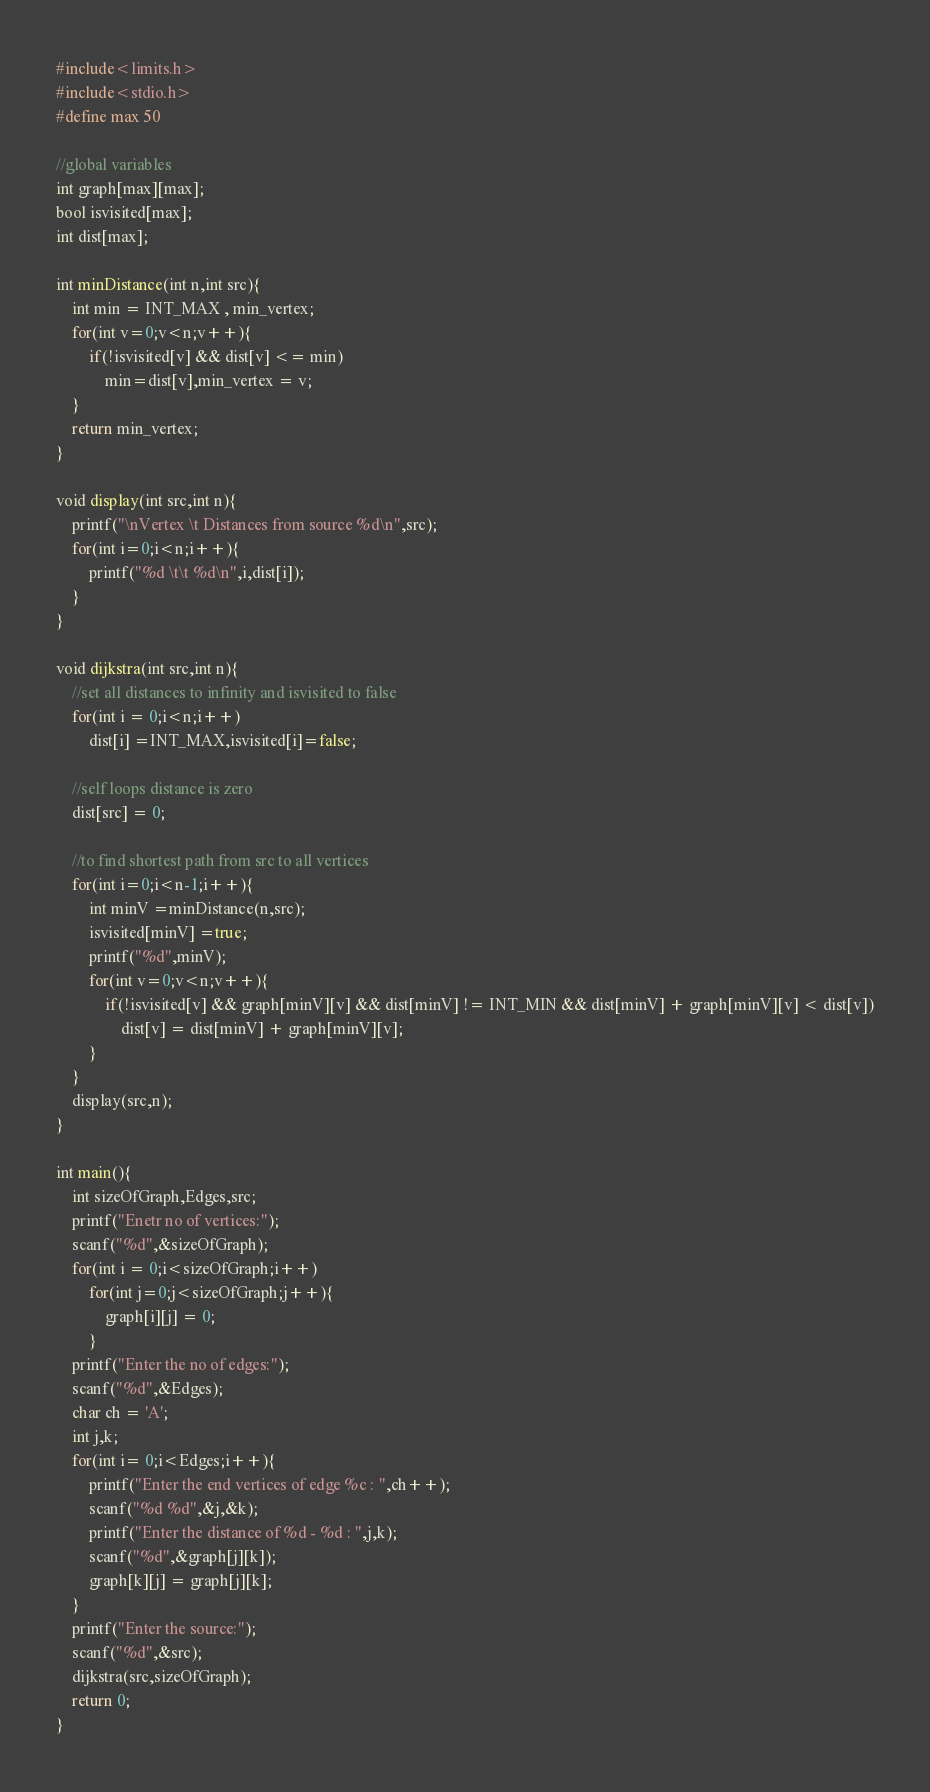Convert code to text. <code><loc_0><loc_0><loc_500><loc_500><_C++_>#include<limits.h>
#include<stdio.h>
#define max 50

//global variables
int graph[max][max];
bool isvisited[max];
int dist[max];

int minDistance(int n,int src){
    int min = INT_MAX , min_vertex;
    for(int v=0;v<n;v++){
        if(!isvisited[v] && dist[v] <= min)
            min=dist[v],min_vertex = v;        
    }
    return min_vertex;
}

void display(int src,int n){
    printf("\nVertex \t Distances from source %d\n",src);
    for(int i=0;i<n;i++){
        printf("%d \t\t %d\n",i,dist[i]);
    }
}

void dijkstra(int src,int n){
    //set all distances to infinity and isvisited to false
    for(int i = 0;i<n;i++)
        dist[i] =INT_MAX,isvisited[i]=false;
    
    //self loops distance is zero
    dist[src] = 0;

    //to find shortest path from src to all vertices
    for(int i=0;i<n-1;i++){
        int minV =minDistance(n,src);
        isvisited[minV] =true;
        printf("%d",minV);
        for(int v=0;v<n;v++){
            if(!isvisited[v] && graph[minV][v] && dist[minV] != INT_MIN && dist[minV] + graph[minV][v] < dist[v])
                dist[v] = dist[minV] + graph[minV][v];
        }
    }
    display(src,n);
}

int main(){
    int sizeOfGraph,Edges,src;
    printf("Enetr no of vertices:");
    scanf("%d",&sizeOfGraph);
    for(int i = 0;i<sizeOfGraph;i++)
        for(int j=0;j<sizeOfGraph;j++){
            graph[i][j] = 0;
        }
    printf("Enter the no of edges:");
    scanf("%d",&Edges);
    char ch = 'A';
    int j,k;
    for(int i= 0;i<Edges;i++){
        printf("Enter the end vertices of edge %c : ",ch++);
        scanf("%d %d",&j,&k);
        printf("Enter the distance of %d - %d : ",j,k);
        scanf("%d",&graph[j][k]);
        graph[k][j] = graph[j][k];
    }    
    printf("Enter the source:");
    scanf("%d",&src);    
    dijkstra(src,sizeOfGraph);    
    return 0;    
}
</code> 